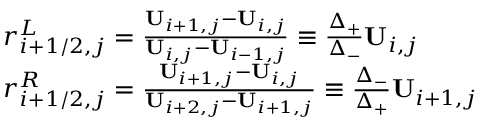Convert formula to latex. <formula><loc_0><loc_0><loc_500><loc_500>\begin{array} { r l } & { r _ { i + 1 / 2 , j } ^ { L } = \frac { U _ { i + 1 , j } - U _ { i , j } } { U _ { i , j } - U _ { i - 1 , j } } \equiv \frac { \Delta _ { + } } { \Delta _ { - } } U _ { i , j } } \\ & { r _ { i + 1 / 2 , j } ^ { R } = \frac { U _ { i + 1 , j } - U _ { i , j } } { U _ { i + 2 , j } - U _ { i + 1 , j } } \equiv \frac { \Delta _ { - } } { \Delta _ { + } } U _ { i + 1 , j } } \end{array}</formula> 